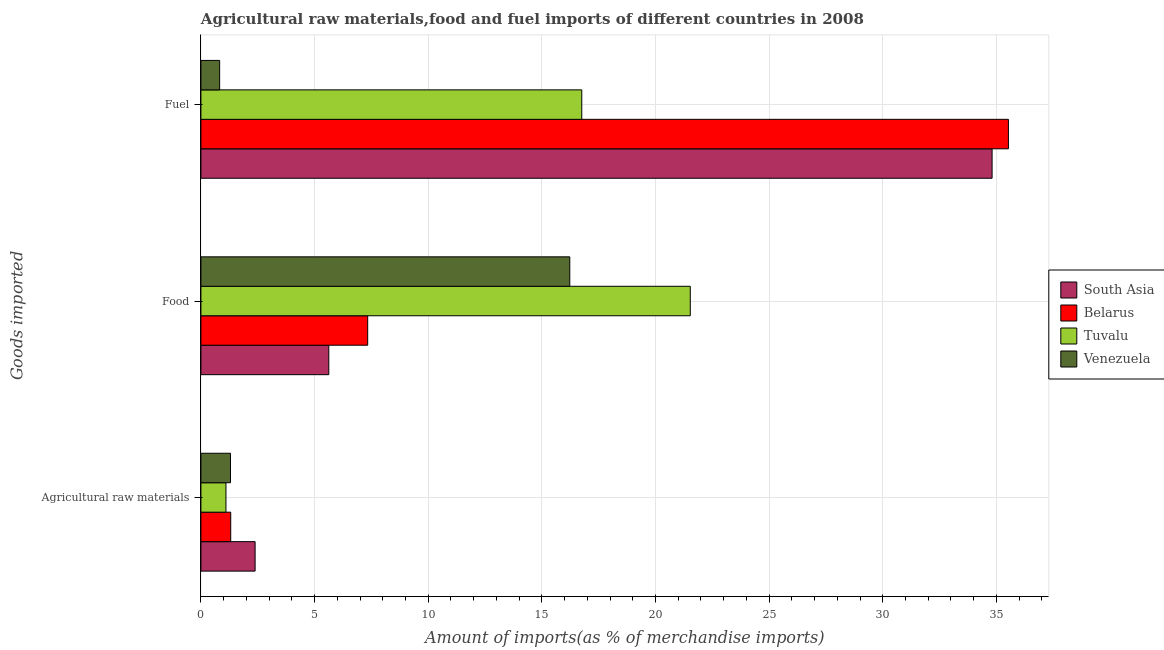How many different coloured bars are there?
Provide a succinct answer. 4. Are the number of bars per tick equal to the number of legend labels?
Give a very brief answer. Yes. What is the label of the 3rd group of bars from the top?
Offer a very short reply. Agricultural raw materials. What is the percentage of fuel imports in Tuvalu?
Make the answer very short. 16.76. Across all countries, what is the maximum percentage of food imports?
Ensure brevity in your answer.  21.53. Across all countries, what is the minimum percentage of raw materials imports?
Give a very brief answer. 1.1. In which country was the percentage of fuel imports maximum?
Your answer should be compact. Belarus. In which country was the percentage of raw materials imports minimum?
Your answer should be very brief. Tuvalu. What is the total percentage of food imports in the graph?
Offer a very short reply. 50.72. What is the difference between the percentage of fuel imports in Venezuela and that in Tuvalu?
Keep it short and to the point. -15.93. What is the difference between the percentage of raw materials imports in Belarus and the percentage of fuel imports in Tuvalu?
Provide a short and direct response. -15.45. What is the average percentage of fuel imports per country?
Make the answer very short. 21.98. What is the difference between the percentage of raw materials imports and percentage of fuel imports in Belarus?
Your response must be concise. -34.22. In how many countries, is the percentage of food imports greater than 21 %?
Offer a terse response. 1. What is the ratio of the percentage of fuel imports in South Asia to that in Tuvalu?
Your answer should be compact. 2.08. Is the difference between the percentage of raw materials imports in Venezuela and Belarus greater than the difference between the percentage of fuel imports in Venezuela and Belarus?
Ensure brevity in your answer.  Yes. What is the difference between the highest and the second highest percentage of fuel imports?
Provide a short and direct response. 0.72. What is the difference between the highest and the lowest percentage of fuel imports?
Your answer should be compact. 34.7. In how many countries, is the percentage of food imports greater than the average percentage of food imports taken over all countries?
Your answer should be compact. 2. Is the sum of the percentage of fuel imports in Belarus and Tuvalu greater than the maximum percentage of raw materials imports across all countries?
Give a very brief answer. Yes. What does the 4th bar from the top in Food represents?
Give a very brief answer. South Asia. What does the 3rd bar from the bottom in Fuel represents?
Make the answer very short. Tuvalu. Is it the case that in every country, the sum of the percentage of raw materials imports and percentage of food imports is greater than the percentage of fuel imports?
Make the answer very short. No. What is the difference between two consecutive major ticks on the X-axis?
Your response must be concise. 5. Does the graph contain any zero values?
Provide a short and direct response. No. Does the graph contain grids?
Give a very brief answer. Yes. How many legend labels are there?
Your answer should be very brief. 4. What is the title of the graph?
Offer a very short reply. Agricultural raw materials,food and fuel imports of different countries in 2008. Does "Romania" appear as one of the legend labels in the graph?
Ensure brevity in your answer.  No. What is the label or title of the X-axis?
Give a very brief answer. Amount of imports(as % of merchandise imports). What is the label or title of the Y-axis?
Provide a short and direct response. Goods imported. What is the Amount of imports(as % of merchandise imports) in South Asia in Agricultural raw materials?
Your answer should be compact. 2.38. What is the Amount of imports(as % of merchandise imports) of Belarus in Agricultural raw materials?
Provide a short and direct response. 1.31. What is the Amount of imports(as % of merchandise imports) of Tuvalu in Agricultural raw materials?
Your response must be concise. 1.1. What is the Amount of imports(as % of merchandise imports) of Venezuela in Agricultural raw materials?
Your answer should be compact. 1.3. What is the Amount of imports(as % of merchandise imports) in South Asia in Food?
Your answer should be compact. 5.63. What is the Amount of imports(as % of merchandise imports) in Belarus in Food?
Offer a very short reply. 7.34. What is the Amount of imports(as % of merchandise imports) of Tuvalu in Food?
Keep it short and to the point. 21.53. What is the Amount of imports(as % of merchandise imports) in Venezuela in Food?
Your response must be concise. 16.23. What is the Amount of imports(as % of merchandise imports) in South Asia in Fuel?
Offer a terse response. 34.81. What is the Amount of imports(as % of merchandise imports) in Belarus in Fuel?
Give a very brief answer. 35.53. What is the Amount of imports(as % of merchandise imports) of Tuvalu in Fuel?
Your answer should be compact. 16.76. What is the Amount of imports(as % of merchandise imports) of Venezuela in Fuel?
Make the answer very short. 0.82. Across all Goods imported, what is the maximum Amount of imports(as % of merchandise imports) in South Asia?
Your response must be concise. 34.81. Across all Goods imported, what is the maximum Amount of imports(as % of merchandise imports) in Belarus?
Offer a terse response. 35.53. Across all Goods imported, what is the maximum Amount of imports(as % of merchandise imports) in Tuvalu?
Ensure brevity in your answer.  21.53. Across all Goods imported, what is the maximum Amount of imports(as % of merchandise imports) of Venezuela?
Provide a short and direct response. 16.23. Across all Goods imported, what is the minimum Amount of imports(as % of merchandise imports) of South Asia?
Keep it short and to the point. 2.38. Across all Goods imported, what is the minimum Amount of imports(as % of merchandise imports) of Belarus?
Give a very brief answer. 1.31. Across all Goods imported, what is the minimum Amount of imports(as % of merchandise imports) of Tuvalu?
Your response must be concise. 1.1. Across all Goods imported, what is the minimum Amount of imports(as % of merchandise imports) of Venezuela?
Keep it short and to the point. 0.82. What is the total Amount of imports(as % of merchandise imports) of South Asia in the graph?
Give a very brief answer. 42.82. What is the total Amount of imports(as % of merchandise imports) of Belarus in the graph?
Your answer should be very brief. 44.18. What is the total Amount of imports(as % of merchandise imports) in Tuvalu in the graph?
Make the answer very short. 39.39. What is the total Amount of imports(as % of merchandise imports) of Venezuela in the graph?
Offer a very short reply. 18.35. What is the difference between the Amount of imports(as % of merchandise imports) in South Asia in Agricultural raw materials and that in Food?
Keep it short and to the point. -3.24. What is the difference between the Amount of imports(as % of merchandise imports) of Belarus in Agricultural raw materials and that in Food?
Keep it short and to the point. -6.03. What is the difference between the Amount of imports(as % of merchandise imports) of Tuvalu in Agricultural raw materials and that in Food?
Offer a terse response. -20.43. What is the difference between the Amount of imports(as % of merchandise imports) in Venezuela in Agricultural raw materials and that in Food?
Provide a short and direct response. -14.93. What is the difference between the Amount of imports(as % of merchandise imports) in South Asia in Agricultural raw materials and that in Fuel?
Give a very brief answer. -32.43. What is the difference between the Amount of imports(as % of merchandise imports) in Belarus in Agricultural raw materials and that in Fuel?
Give a very brief answer. -34.22. What is the difference between the Amount of imports(as % of merchandise imports) of Tuvalu in Agricultural raw materials and that in Fuel?
Keep it short and to the point. -15.66. What is the difference between the Amount of imports(as % of merchandise imports) of Venezuela in Agricultural raw materials and that in Fuel?
Your answer should be compact. 0.48. What is the difference between the Amount of imports(as % of merchandise imports) in South Asia in Food and that in Fuel?
Give a very brief answer. -29.18. What is the difference between the Amount of imports(as % of merchandise imports) in Belarus in Food and that in Fuel?
Give a very brief answer. -28.19. What is the difference between the Amount of imports(as % of merchandise imports) of Tuvalu in Food and that in Fuel?
Ensure brevity in your answer.  4.77. What is the difference between the Amount of imports(as % of merchandise imports) of Venezuela in Food and that in Fuel?
Your answer should be compact. 15.41. What is the difference between the Amount of imports(as % of merchandise imports) in South Asia in Agricultural raw materials and the Amount of imports(as % of merchandise imports) in Belarus in Food?
Give a very brief answer. -4.95. What is the difference between the Amount of imports(as % of merchandise imports) of South Asia in Agricultural raw materials and the Amount of imports(as % of merchandise imports) of Tuvalu in Food?
Keep it short and to the point. -19.15. What is the difference between the Amount of imports(as % of merchandise imports) of South Asia in Agricultural raw materials and the Amount of imports(as % of merchandise imports) of Venezuela in Food?
Provide a succinct answer. -13.85. What is the difference between the Amount of imports(as % of merchandise imports) in Belarus in Agricultural raw materials and the Amount of imports(as % of merchandise imports) in Tuvalu in Food?
Provide a short and direct response. -20.22. What is the difference between the Amount of imports(as % of merchandise imports) of Belarus in Agricultural raw materials and the Amount of imports(as % of merchandise imports) of Venezuela in Food?
Keep it short and to the point. -14.92. What is the difference between the Amount of imports(as % of merchandise imports) in Tuvalu in Agricultural raw materials and the Amount of imports(as % of merchandise imports) in Venezuela in Food?
Offer a terse response. -15.13. What is the difference between the Amount of imports(as % of merchandise imports) of South Asia in Agricultural raw materials and the Amount of imports(as % of merchandise imports) of Belarus in Fuel?
Offer a very short reply. -33.14. What is the difference between the Amount of imports(as % of merchandise imports) of South Asia in Agricultural raw materials and the Amount of imports(as % of merchandise imports) of Tuvalu in Fuel?
Offer a very short reply. -14.37. What is the difference between the Amount of imports(as % of merchandise imports) in South Asia in Agricultural raw materials and the Amount of imports(as % of merchandise imports) in Venezuela in Fuel?
Your answer should be compact. 1.56. What is the difference between the Amount of imports(as % of merchandise imports) of Belarus in Agricultural raw materials and the Amount of imports(as % of merchandise imports) of Tuvalu in Fuel?
Offer a very short reply. -15.45. What is the difference between the Amount of imports(as % of merchandise imports) of Belarus in Agricultural raw materials and the Amount of imports(as % of merchandise imports) of Venezuela in Fuel?
Provide a succinct answer. 0.49. What is the difference between the Amount of imports(as % of merchandise imports) of Tuvalu in Agricultural raw materials and the Amount of imports(as % of merchandise imports) of Venezuela in Fuel?
Offer a terse response. 0.28. What is the difference between the Amount of imports(as % of merchandise imports) of South Asia in Food and the Amount of imports(as % of merchandise imports) of Belarus in Fuel?
Provide a short and direct response. -29.9. What is the difference between the Amount of imports(as % of merchandise imports) in South Asia in Food and the Amount of imports(as % of merchandise imports) in Tuvalu in Fuel?
Your answer should be compact. -11.13. What is the difference between the Amount of imports(as % of merchandise imports) of South Asia in Food and the Amount of imports(as % of merchandise imports) of Venezuela in Fuel?
Provide a short and direct response. 4.8. What is the difference between the Amount of imports(as % of merchandise imports) in Belarus in Food and the Amount of imports(as % of merchandise imports) in Tuvalu in Fuel?
Your response must be concise. -9.42. What is the difference between the Amount of imports(as % of merchandise imports) of Belarus in Food and the Amount of imports(as % of merchandise imports) of Venezuela in Fuel?
Your answer should be very brief. 6.51. What is the difference between the Amount of imports(as % of merchandise imports) of Tuvalu in Food and the Amount of imports(as % of merchandise imports) of Venezuela in Fuel?
Your answer should be very brief. 20.71. What is the average Amount of imports(as % of merchandise imports) of South Asia per Goods imported?
Make the answer very short. 14.27. What is the average Amount of imports(as % of merchandise imports) in Belarus per Goods imported?
Provide a short and direct response. 14.73. What is the average Amount of imports(as % of merchandise imports) in Tuvalu per Goods imported?
Your response must be concise. 13.13. What is the average Amount of imports(as % of merchandise imports) in Venezuela per Goods imported?
Offer a very short reply. 6.12. What is the difference between the Amount of imports(as % of merchandise imports) in South Asia and Amount of imports(as % of merchandise imports) in Belarus in Agricultural raw materials?
Offer a very short reply. 1.07. What is the difference between the Amount of imports(as % of merchandise imports) in South Asia and Amount of imports(as % of merchandise imports) in Tuvalu in Agricultural raw materials?
Your answer should be compact. 1.28. What is the difference between the Amount of imports(as % of merchandise imports) in South Asia and Amount of imports(as % of merchandise imports) in Venezuela in Agricultural raw materials?
Offer a very short reply. 1.08. What is the difference between the Amount of imports(as % of merchandise imports) of Belarus and Amount of imports(as % of merchandise imports) of Tuvalu in Agricultural raw materials?
Your answer should be very brief. 0.21. What is the difference between the Amount of imports(as % of merchandise imports) in Belarus and Amount of imports(as % of merchandise imports) in Venezuela in Agricultural raw materials?
Ensure brevity in your answer.  0.01. What is the difference between the Amount of imports(as % of merchandise imports) of Tuvalu and Amount of imports(as % of merchandise imports) of Venezuela in Agricultural raw materials?
Your answer should be very brief. -0.2. What is the difference between the Amount of imports(as % of merchandise imports) in South Asia and Amount of imports(as % of merchandise imports) in Belarus in Food?
Your response must be concise. -1.71. What is the difference between the Amount of imports(as % of merchandise imports) in South Asia and Amount of imports(as % of merchandise imports) in Tuvalu in Food?
Provide a succinct answer. -15.9. What is the difference between the Amount of imports(as % of merchandise imports) in South Asia and Amount of imports(as % of merchandise imports) in Venezuela in Food?
Your response must be concise. -10.6. What is the difference between the Amount of imports(as % of merchandise imports) of Belarus and Amount of imports(as % of merchandise imports) of Tuvalu in Food?
Provide a short and direct response. -14.19. What is the difference between the Amount of imports(as % of merchandise imports) in Belarus and Amount of imports(as % of merchandise imports) in Venezuela in Food?
Offer a terse response. -8.89. What is the difference between the Amount of imports(as % of merchandise imports) of Tuvalu and Amount of imports(as % of merchandise imports) of Venezuela in Food?
Provide a succinct answer. 5.3. What is the difference between the Amount of imports(as % of merchandise imports) of South Asia and Amount of imports(as % of merchandise imports) of Belarus in Fuel?
Keep it short and to the point. -0.72. What is the difference between the Amount of imports(as % of merchandise imports) in South Asia and Amount of imports(as % of merchandise imports) in Tuvalu in Fuel?
Make the answer very short. 18.05. What is the difference between the Amount of imports(as % of merchandise imports) in South Asia and Amount of imports(as % of merchandise imports) in Venezuela in Fuel?
Provide a succinct answer. 33.99. What is the difference between the Amount of imports(as % of merchandise imports) of Belarus and Amount of imports(as % of merchandise imports) of Tuvalu in Fuel?
Make the answer very short. 18.77. What is the difference between the Amount of imports(as % of merchandise imports) of Belarus and Amount of imports(as % of merchandise imports) of Venezuela in Fuel?
Give a very brief answer. 34.7. What is the difference between the Amount of imports(as % of merchandise imports) of Tuvalu and Amount of imports(as % of merchandise imports) of Venezuela in Fuel?
Your answer should be very brief. 15.93. What is the ratio of the Amount of imports(as % of merchandise imports) of South Asia in Agricultural raw materials to that in Food?
Offer a very short reply. 0.42. What is the ratio of the Amount of imports(as % of merchandise imports) in Belarus in Agricultural raw materials to that in Food?
Ensure brevity in your answer.  0.18. What is the ratio of the Amount of imports(as % of merchandise imports) in Tuvalu in Agricultural raw materials to that in Food?
Offer a terse response. 0.05. What is the ratio of the Amount of imports(as % of merchandise imports) of Venezuela in Agricultural raw materials to that in Food?
Your answer should be very brief. 0.08. What is the ratio of the Amount of imports(as % of merchandise imports) of South Asia in Agricultural raw materials to that in Fuel?
Offer a very short reply. 0.07. What is the ratio of the Amount of imports(as % of merchandise imports) in Belarus in Agricultural raw materials to that in Fuel?
Give a very brief answer. 0.04. What is the ratio of the Amount of imports(as % of merchandise imports) of Tuvalu in Agricultural raw materials to that in Fuel?
Keep it short and to the point. 0.07. What is the ratio of the Amount of imports(as % of merchandise imports) of Venezuela in Agricultural raw materials to that in Fuel?
Provide a short and direct response. 1.58. What is the ratio of the Amount of imports(as % of merchandise imports) in South Asia in Food to that in Fuel?
Give a very brief answer. 0.16. What is the ratio of the Amount of imports(as % of merchandise imports) in Belarus in Food to that in Fuel?
Provide a short and direct response. 0.21. What is the ratio of the Amount of imports(as % of merchandise imports) of Tuvalu in Food to that in Fuel?
Your response must be concise. 1.28. What is the ratio of the Amount of imports(as % of merchandise imports) of Venezuela in Food to that in Fuel?
Provide a succinct answer. 19.7. What is the difference between the highest and the second highest Amount of imports(as % of merchandise imports) in South Asia?
Your response must be concise. 29.18. What is the difference between the highest and the second highest Amount of imports(as % of merchandise imports) in Belarus?
Your response must be concise. 28.19. What is the difference between the highest and the second highest Amount of imports(as % of merchandise imports) in Tuvalu?
Your answer should be very brief. 4.77. What is the difference between the highest and the second highest Amount of imports(as % of merchandise imports) in Venezuela?
Provide a short and direct response. 14.93. What is the difference between the highest and the lowest Amount of imports(as % of merchandise imports) of South Asia?
Provide a succinct answer. 32.43. What is the difference between the highest and the lowest Amount of imports(as % of merchandise imports) in Belarus?
Offer a very short reply. 34.22. What is the difference between the highest and the lowest Amount of imports(as % of merchandise imports) of Tuvalu?
Keep it short and to the point. 20.43. What is the difference between the highest and the lowest Amount of imports(as % of merchandise imports) of Venezuela?
Give a very brief answer. 15.41. 